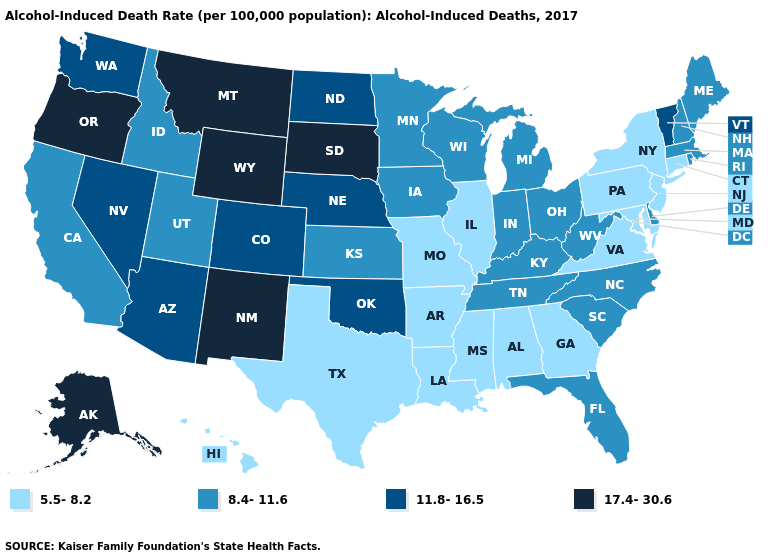What is the value of Nevada?
Give a very brief answer. 11.8-16.5. Does the map have missing data?
Answer briefly. No. What is the value of Kansas?
Answer briefly. 8.4-11.6. Name the states that have a value in the range 17.4-30.6?
Answer briefly. Alaska, Montana, New Mexico, Oregon, South Dakota, Wyoming. Does the map have missing data?
Keep it brief. No. Among the states that border Wyoming , does Idaho have the lowest value?
Be succinct. Yes. Which states hav the highest value in the Northeast?
Keep it brief. Vermont. What is the value of New Mexico?
Concise answer only. 17.4-30.6. Name the states that have a value in the range 11.8-16.5?
Write a very short answer. Arizona, Colorado, Nebraska, Nevada, North Dakota, Oklahoma, Vermont, Washington. Name the states that have a value in the range 11.8-16.5?
Keep it brief. Arizona, Colorado, Nebraska, Nevada, North Dakota, Oklahoma, Vermont, Washington. Among the states that border Missouri , does Illinois have the lowest value?
Quick response, please. Yes. Name the states that have a value in the range 8.4-11.6?
Give a very brief answer. California, Delaware, Florida, Idaho, Indiana, Iowa, Kansas, Kentucky, Maine, Massachusetts, Michigan, Minnesota, New Hampshire, North Carolina, Ohio, Rhode Island, South Carolina, Tennessee, Utah, West Virginia, Wisconsin. What is the value of Illinois?
Give a very brief answer. 5.5-8.2. What is the highest value in states that border Nevada?
Quick response, please. 17.4-30.6. What is the value of Kansas?
Be succinct. 8.4-11.6. 